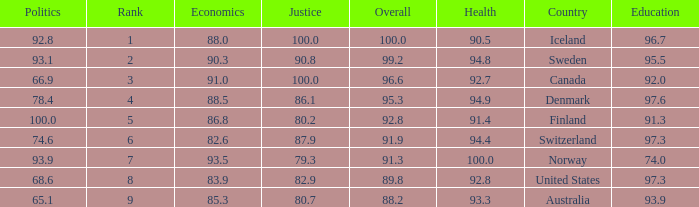What's the economics score with education being 92.0 91.0. 